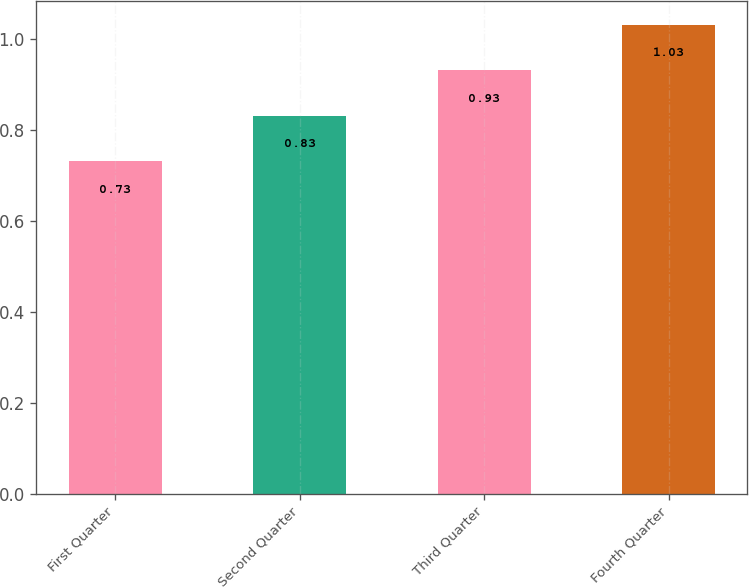Convert chart. <chart><loc_0><loc_0><loc_500><loc_500><bar_chart><fcel>First Quarter<fcel>Second Quarter<fcel>Third Quarter<fcel>Fourth Quarter<nl><fcel>0.73<fcel>0.83<fcel>0.93<fcel>1.03<nl></chart> 